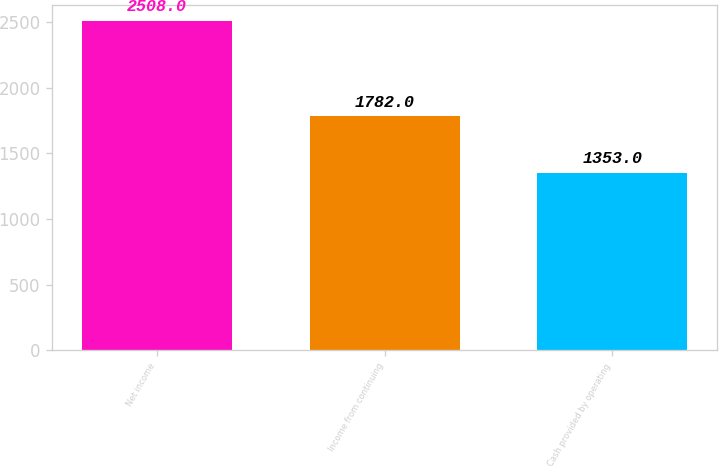Convert chart to OTSL. <chart><loc_0><loc_0><loc_500><loc_500><bar_chart><fcel>Net income<fcel>Income from continuing<fcel>Cash provided by operating<nl><fcel>2508<fcel>1782<fcel>1353<nl></chart> 